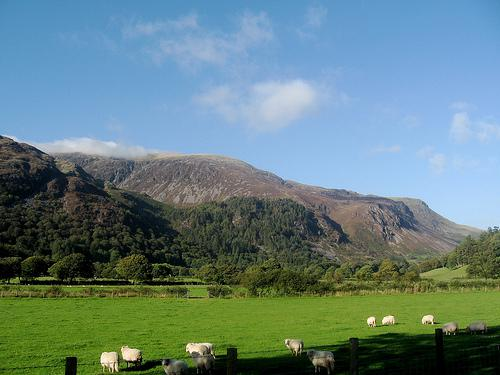Question: what is in the background?
Choices:
A. Mountains.
B. Hills.
C. Ocean.
D. Trees.
Answer with the letter. Answer: A Question: what is the color of the grass?
Choices:
A. Yellow.
B. Red.
C. Green.
D. Black.
Answer with the letter. Answer: C Question: when is the color of the sheep?
Choices:
A. Black.
B. Gray.
C. White.
D. Purple.
Answer with the letter. Answer: C Question: how many people flying?
Choices:
A. Zero.
B. One.
C. Two.
D. Three.
Answer with the letter. Answer: A Question: what is the color of the sky?
Choices:
A. Purple and red.
B. Blue and white.
C. Yellow and red.
D. Gray and white.
Answer with the letter. Answer: B 